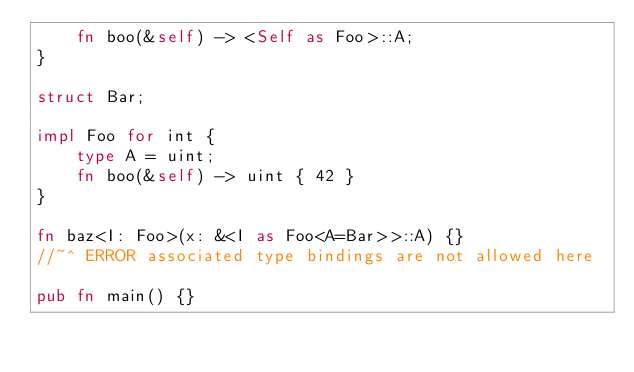Convert code to text. <code><loc_0><loc_0><loc_500><loc_500><_Rust_>    fn boo(&self) -> <Self as Foo>::A;
}

struct Bar;

impl Foo for int {
    type A = uint;
    fn boo(&self) -> uint { 42 }
}

fn baz<I: Foo>(x: &<I as Foo<A=Bar>>::A) {}
//~^ ERROR associated type bindings are not allowed here

pub fn main() {}
</code> 